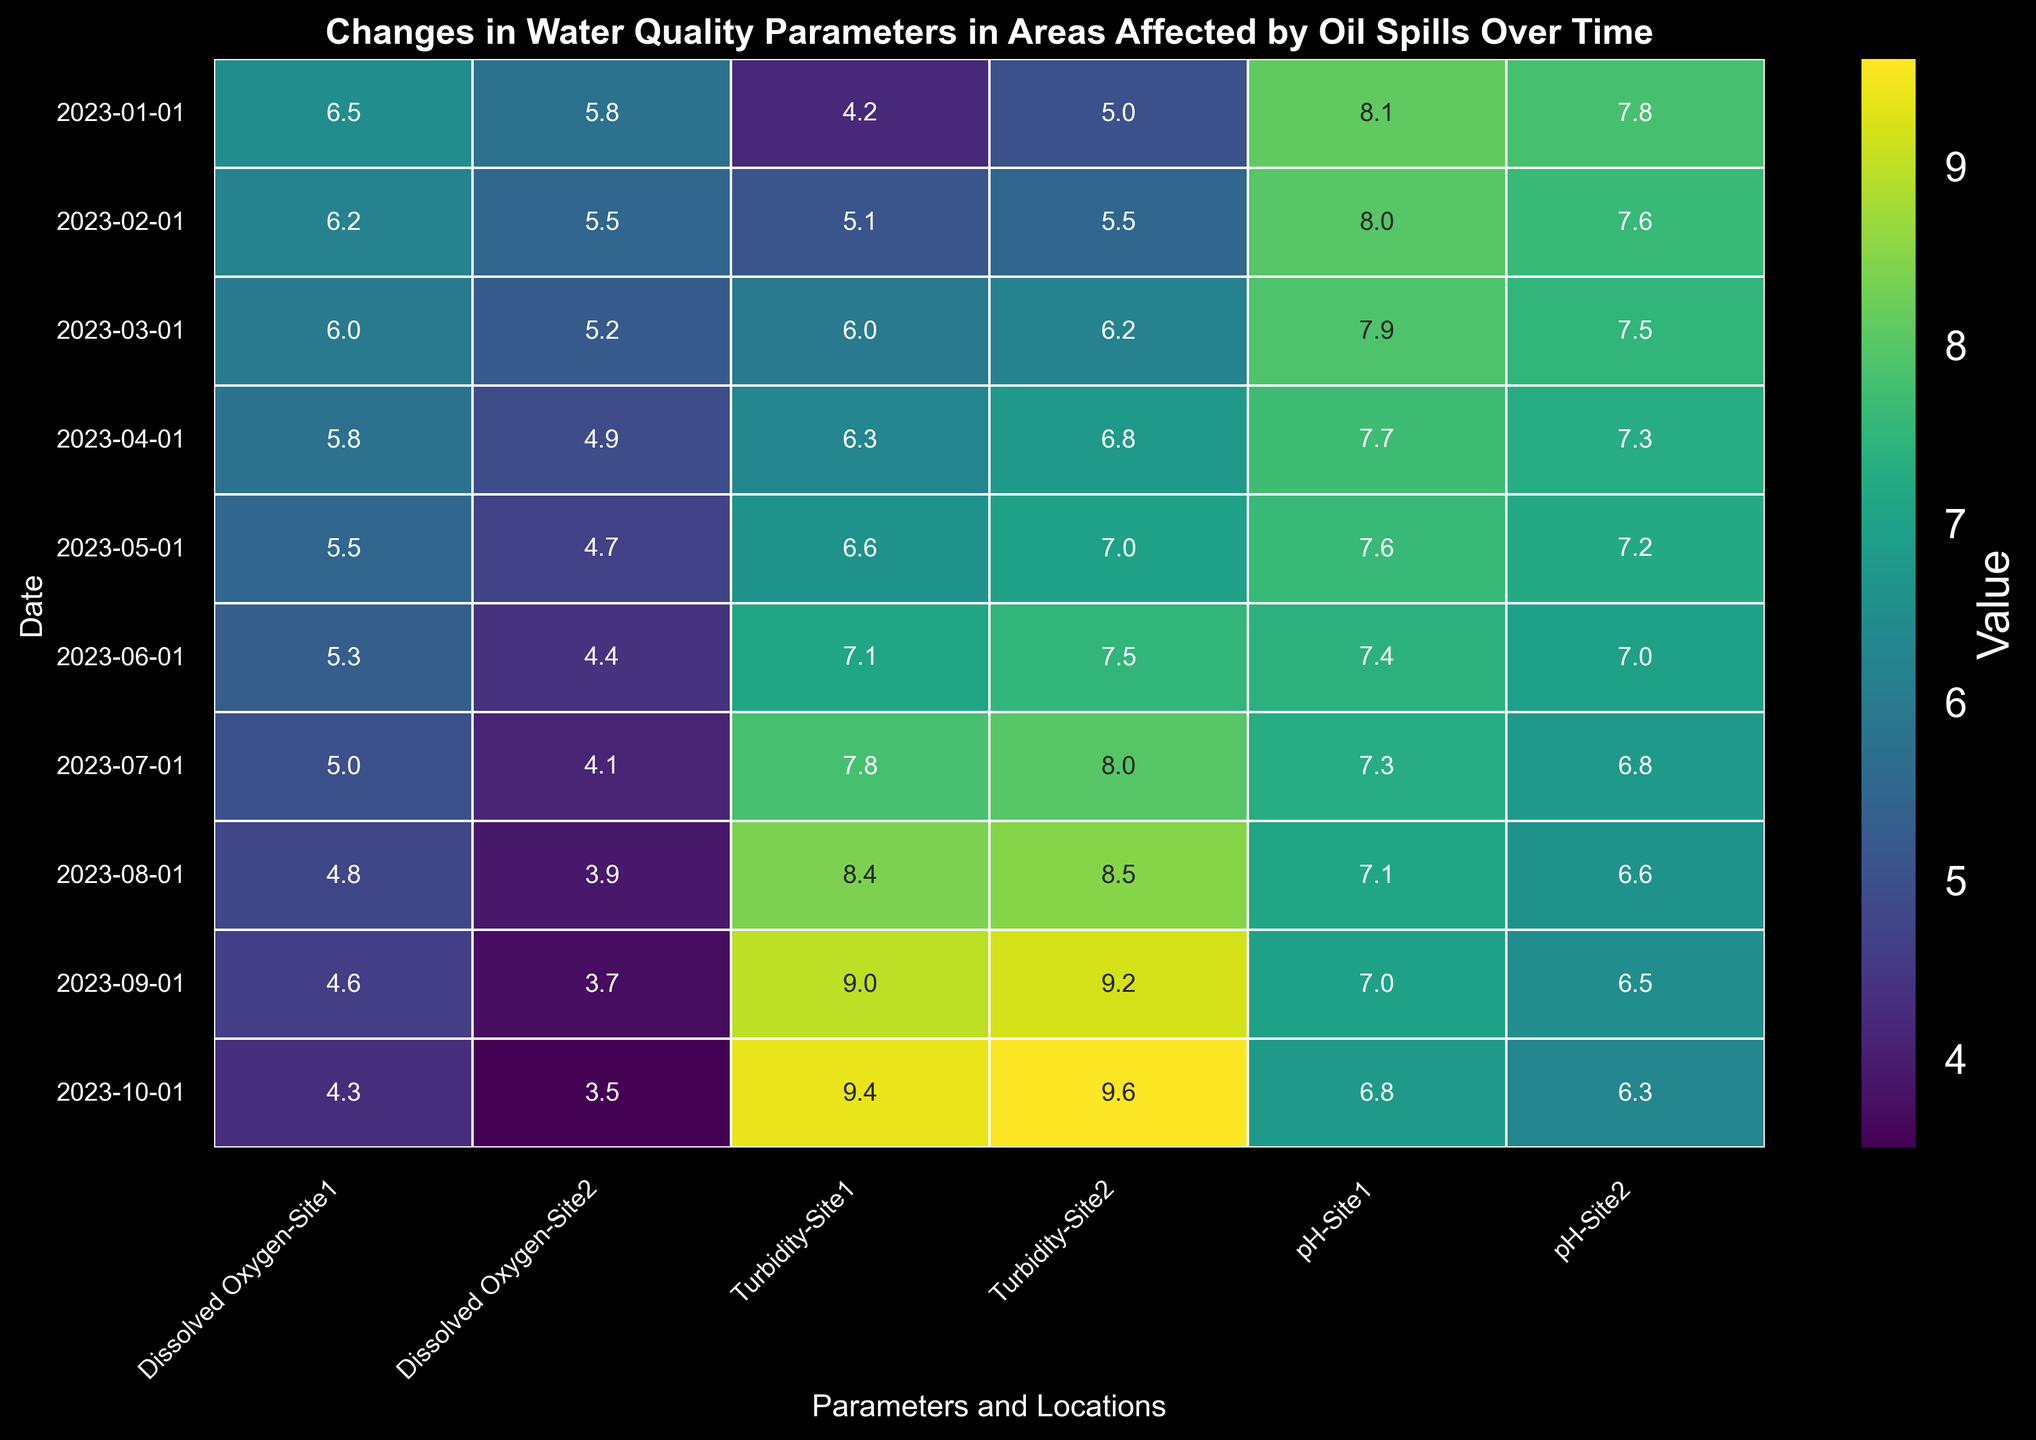what month did Site 1 have the lowest pH? Scan through the pH values for Site 1 and identify the lowest value which corresponds to the month of October 2023
Answer: October 2023 Which location had higher turbidity in July 2023? Compare the turbidity values for Site 1 and Site 2 in July 2023. Site 1 has a turbidity value of 7.8 and Site 2 has a turbidity value of 8.0, so Site 2 had higher turbidity
Answer: Site 2 What is the difference in dissolved oxygen levels between Site 1 and Site 2 in February 2023? Check the dissolved oxygen levels for both sites in February 2023. Site 1 has 6.2 and Site 2 has 5.5. The difference is 6.2 - 5.5 = 0.7
Answer: 0.7 How did the pH at Site 1 change from January 2023 to October 2023? Note the pH values for Site 1 in January 2023 (8.1) and October 2023 (6.8). Calculate the change as 6.8 - 8.1, which is a decrease of 1.3
Answer: Decreased by 1.3 Which site had the greater decrease in dissolved oxygen from January 2023 to October 2023? Compare the dissolved oxygen change from January to October for both sites. Site 1's DO decreased from 6.5 to 4.3 (decrease of 2.2), and Site 2's DO decreased from 5.8 to 3.5 (decrease of 2.3). Site 2 had a slightly greater decrease
Answer: Site 2 In which month was the turbidity highest for Site 1? Examine the turbidity values for Site 1 across all months. The highest figure is 9.4 in October 2023
Answer: October 2023 What is the average pH value for Site 2 across all months? Sum the pH values for Site 2 across months and divide by the number of months: (7.8 + 7.6 + 7.5 + 7.3 + 7.2 + 7.0 + 6.8 + 6.6 + 6.5 + 6.3)/10 = 6.96
Answer: 6.96 What parameter shows the greatest variation at Site 1 over time? Compare the range (max - min) of each parameter's values at Site 1. The ranges are: pH: 8.1-6.8 = 1.3, Dissolved Oxygen: 6.5-4.3=2.2, Turbidity: 9.4-4.2=5.2. Turbidity has the greatest variation
Answer: Turbidity How did the turbidity at Site 2 change from May 2023 to June 2023? Identify the turbidity values for Site 2 in May (7.0) and June (7.5). The change is 7.5 - 7.0 = 0.5, an increase
Answer: Increased by 0.5 